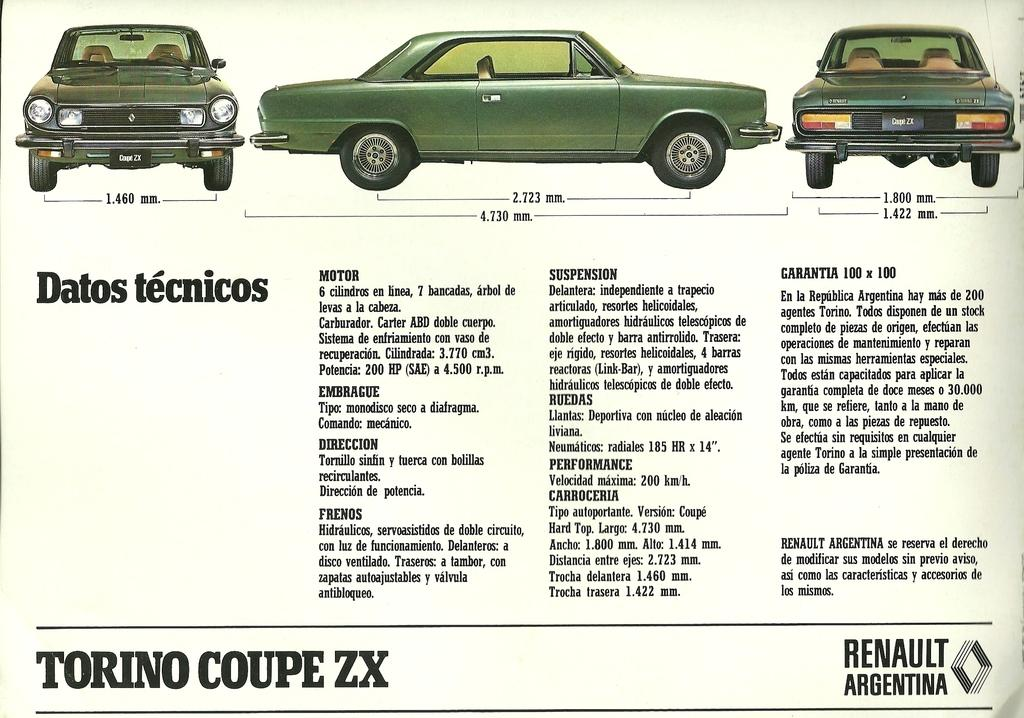What type of visual medium is the image? The image appears to be a poster. What is shown on the poster? There are cars depicted on the poster. Are there any words or phrases on the poster? Yes, there is text present on the poster. How many tomatoes are placed on the hood of the car in the image? There are no tomatoes present in the image; it features a poster with cars and text. Is there an owl perched on the roof of the car in the image? There is no owl present in the image; it only shows cars and text on a poster. 